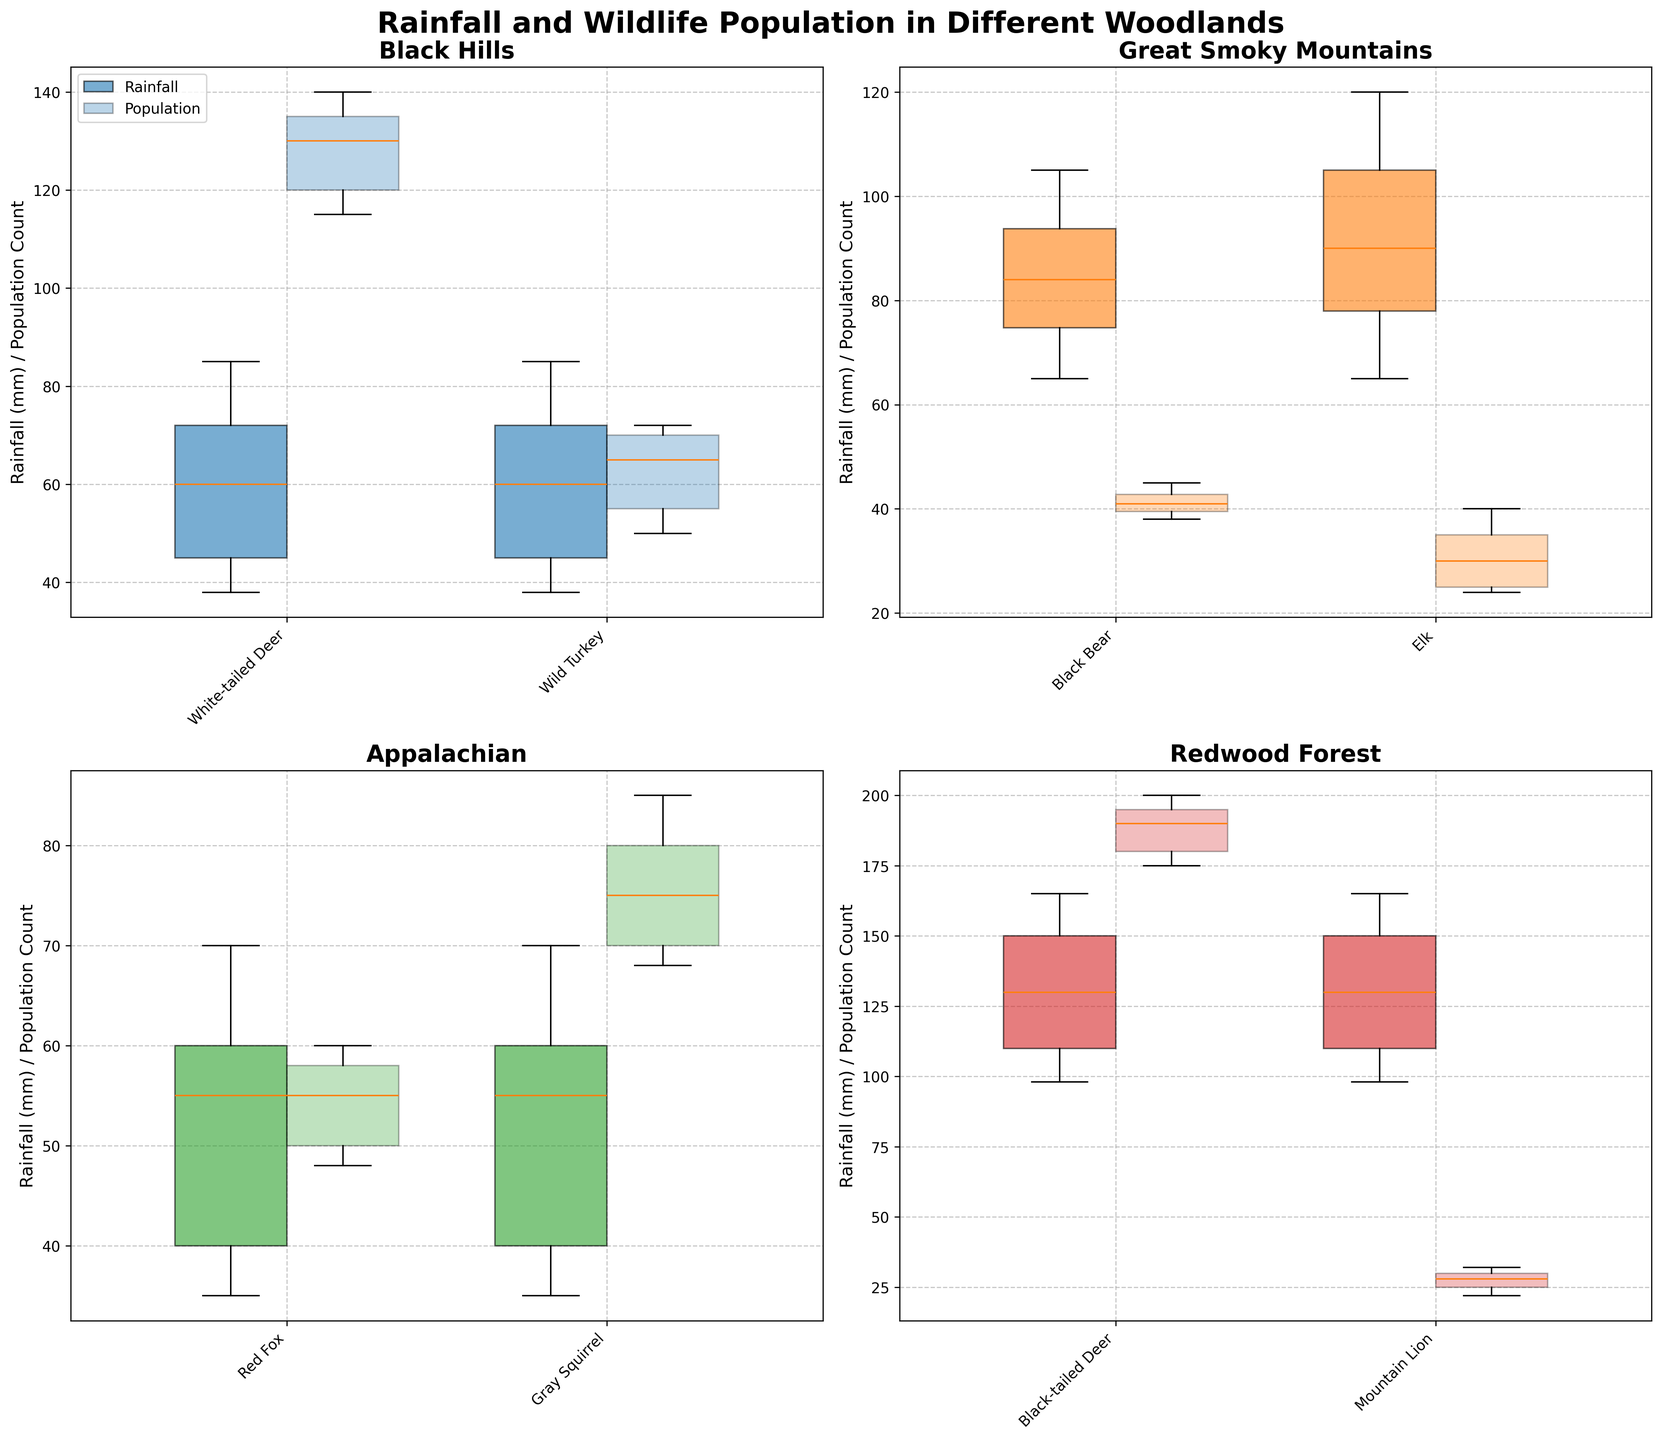What is the title of the plot in the Black Hills region? The title of the plot is usually displayed at the top of each subplot. It identifies the region presented by the subplot. In this case, by looking at the top of the Black Hills subplot, you can see the title.
Answer: Rainfall and Wildlife Population in Different Woodlands How does the rainfall vary for the White-tailed Deer in the Black Hills region? To determine the variation in rainfall, you need to refer to the range of the box plot for the White-tailed Deer in the Black Hills region. Locate the box plot for rainfall (likely the one shown in a specific color) for this species in the corresponding subplot.
Answer: 38-85 mm What is the median population count of the Mountain Lion in Redwood Forest for the month of May? Find the box plot representing the population of the Mountain Lion in Redwood Forest. The median is typically marked by the horizontal line inside the box. Locate the value of this line on the y-axis in the relevant subplot.
Answer: 30 How do the populations of Red Foxes compare to Gray Squirrels in the Appalachian region? Look at the box plots for the populations of both species in the Appalachian subplot. Compare the central tendency (median) and the interquartile range (IQR) for both populations to make an assessment.
Answer: Gray Squirrels have higher population counts than Red Foxes In which region does April have the highest recorded rainfall and for which species is it? Check the box plots representing April rainfall across all regions and species. Compare the maximum values indicated by the whiskers or outliers of the box plots for April. Identify the highest one.
Answer: Great Smoky Mountains, Black Bear Comparing the White-tailed Deer populations in the Black Hills region over the months, which month shows the highest population count? Refer to the box plots representing population count for the White-tailed Deer in the Black Hills subplot. Look for the highest median or maximum value indicated by the plots over the months.
Answer: April Which region has the largest interquartile range (IQR) for rainfall in March? Check the box plots for March rainfall across all regions. The interquartile range is the distance between the first and third quartiles of the box plot (the box itself). Identify the region with the largest box height.
Answer: Redwood Forest Does the Wild Turkey population in the Black Hills region increase or decrease over the months shown? Observe the trend in the median or central values of the box plots for Wild Turkey population in the Black Hills region across the months. Note if the values generally rise or fall.
Answer: Increases Which species has the smallest population in the Great Smoky Mountains region in May? Refer to the box plots for population counts in May for the Great Smoky Mountains. Identify the species with the lowest median population count.
Answer: Elk 